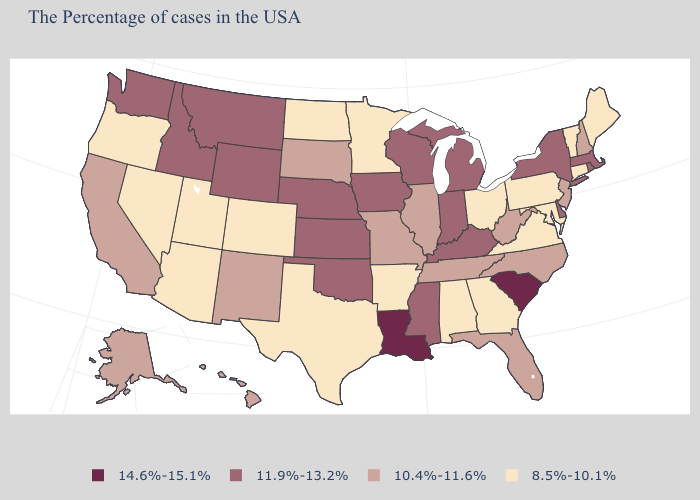What is the value of Louisiana?
Be succinct. 14.6%-15.1%. Name the states that have a value in the range 11.9%-13.2%?
Short answer required. Massachusetts, Rhode Island, New York, Delaware, Michigan, Kentucky, Indiana, Wisconsin, Mississippi, Iowa, Kansas, Nebraska, Oklahoma, Wyoming, Montana, Idaho, Washington. What is the lowest value in the USA?
Give a very brief answer. 8.5%-10.1%. What is the value of Wisconsin?
Concise answer only. 11.9%-13.2%. What is the value of Rhode Island?
Be succinct. 11.9%-13.2%. What is the value of Alaska?
Quick response, please. 10.4%-11.6%. Does the map have missing data?
Quick response, please. No. Does Louisiana have the highest value in the South?
Keep it brief. Yes. Name the states that have a value in the range 14.6%-15.1%?
Short answer required. South Carolina, Louisiana. Among the states that border South Carolina , does Georgia have the lowest value?
Write a very short answer. Yes. Is the legend a continuous bar?
Write a very short answer. No. Name the states that have a value in the range 14.6%-15.1%?
Write a very short answer. South Carolina, Louisiana. How many symbols are there in the legend?
Write a very short answer. 4. Does Alaska have the same value as Illinois?
Give a very brief answer. Yes. Does Massachusetts have the highest value in the Northeast?
Quick response, please. Yes. 